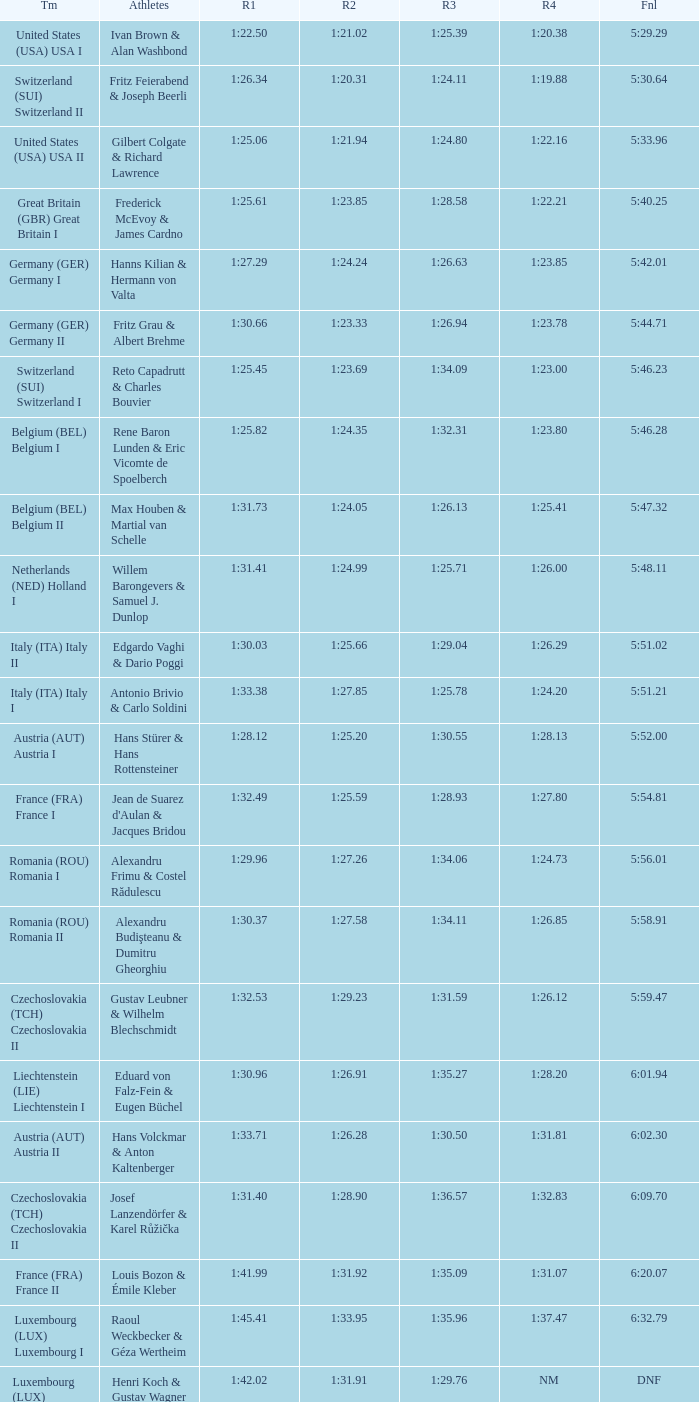Which Run 2 has a Run 1 of 1:30.03? 1:25.66. 